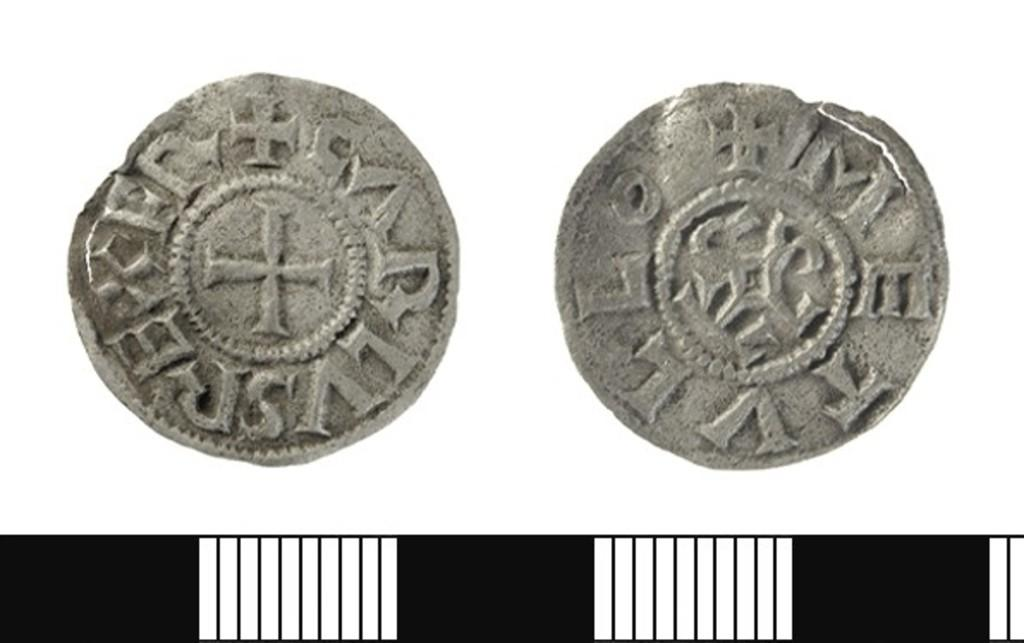<image>
Create a compact narrative representing the image presented. Two old coins that both have the letter V on the outside edge 